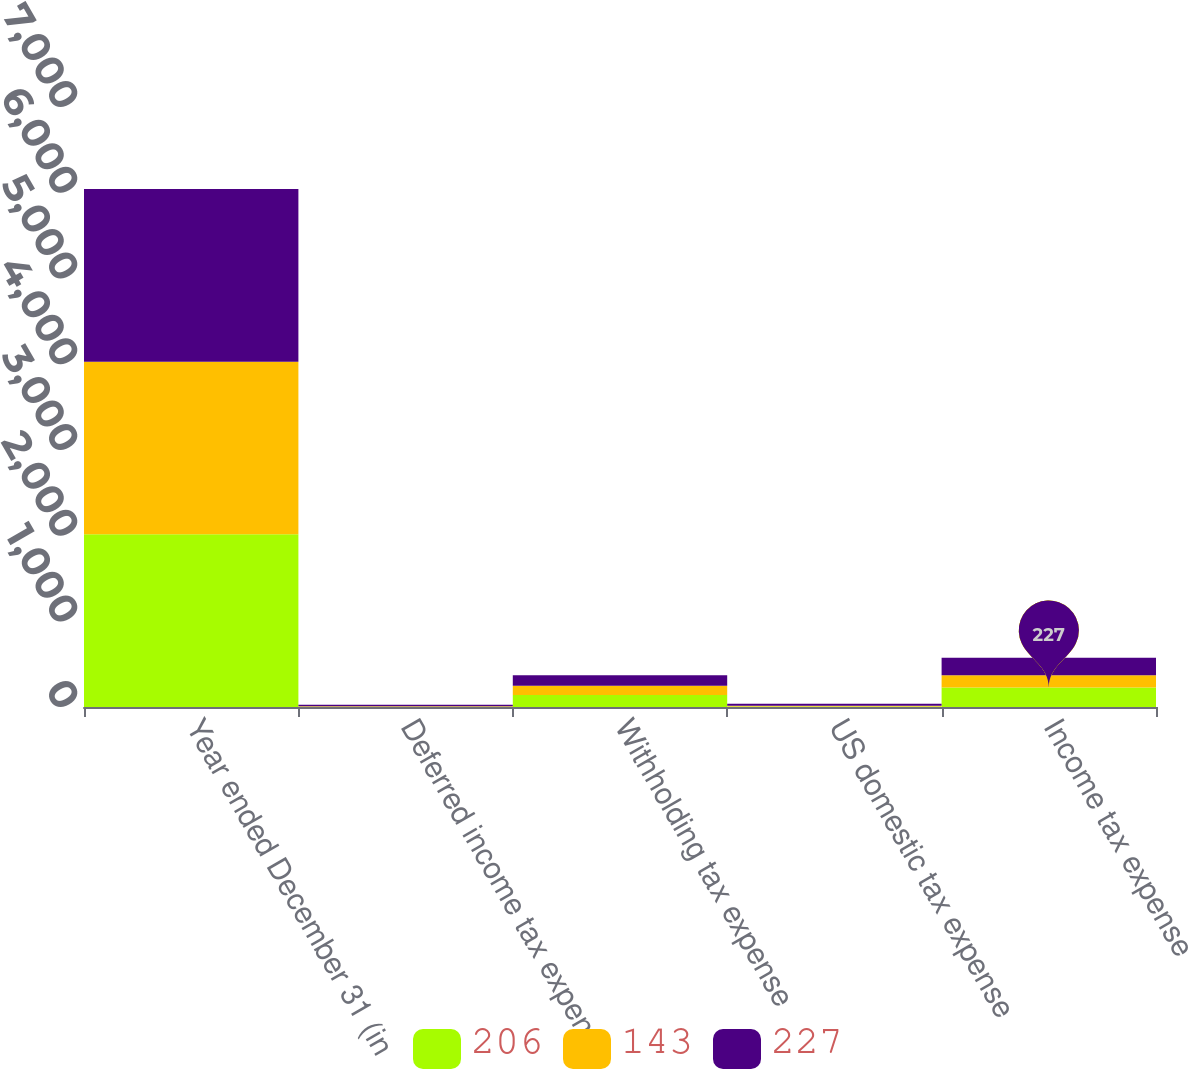Convert chart to OTSL. <chart><loc_0><loc_0><loc_500><loc_500><stacked_bar_chart><ecel><fcel>Year ended December 31 (in<fcel>Deferred income tax expense<fcel>Withholding tax expense<fcel>US domestic tax expense<fcel>Income tax expense<nl><fcel>206<fcel>2015<fcel>2<fcel>139<fcel>5<fcel>227<nl><fcel>143<fcel>2014<fcel>8<fcel>108<fcel>10<fcel>143<nl><fcel>227<fcel>2013<fcel>16<fcel>123<fcel>22<fcel>206<nl></chart> 